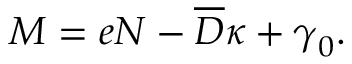<formula> <loc_0><loc_0><loc_500><loc_500>\begin{array} { r } { { M } = { e } { N } - { \overline { D } } { \kappa } + { \gamma } _ { 0 } . } \end{array}</formula> 